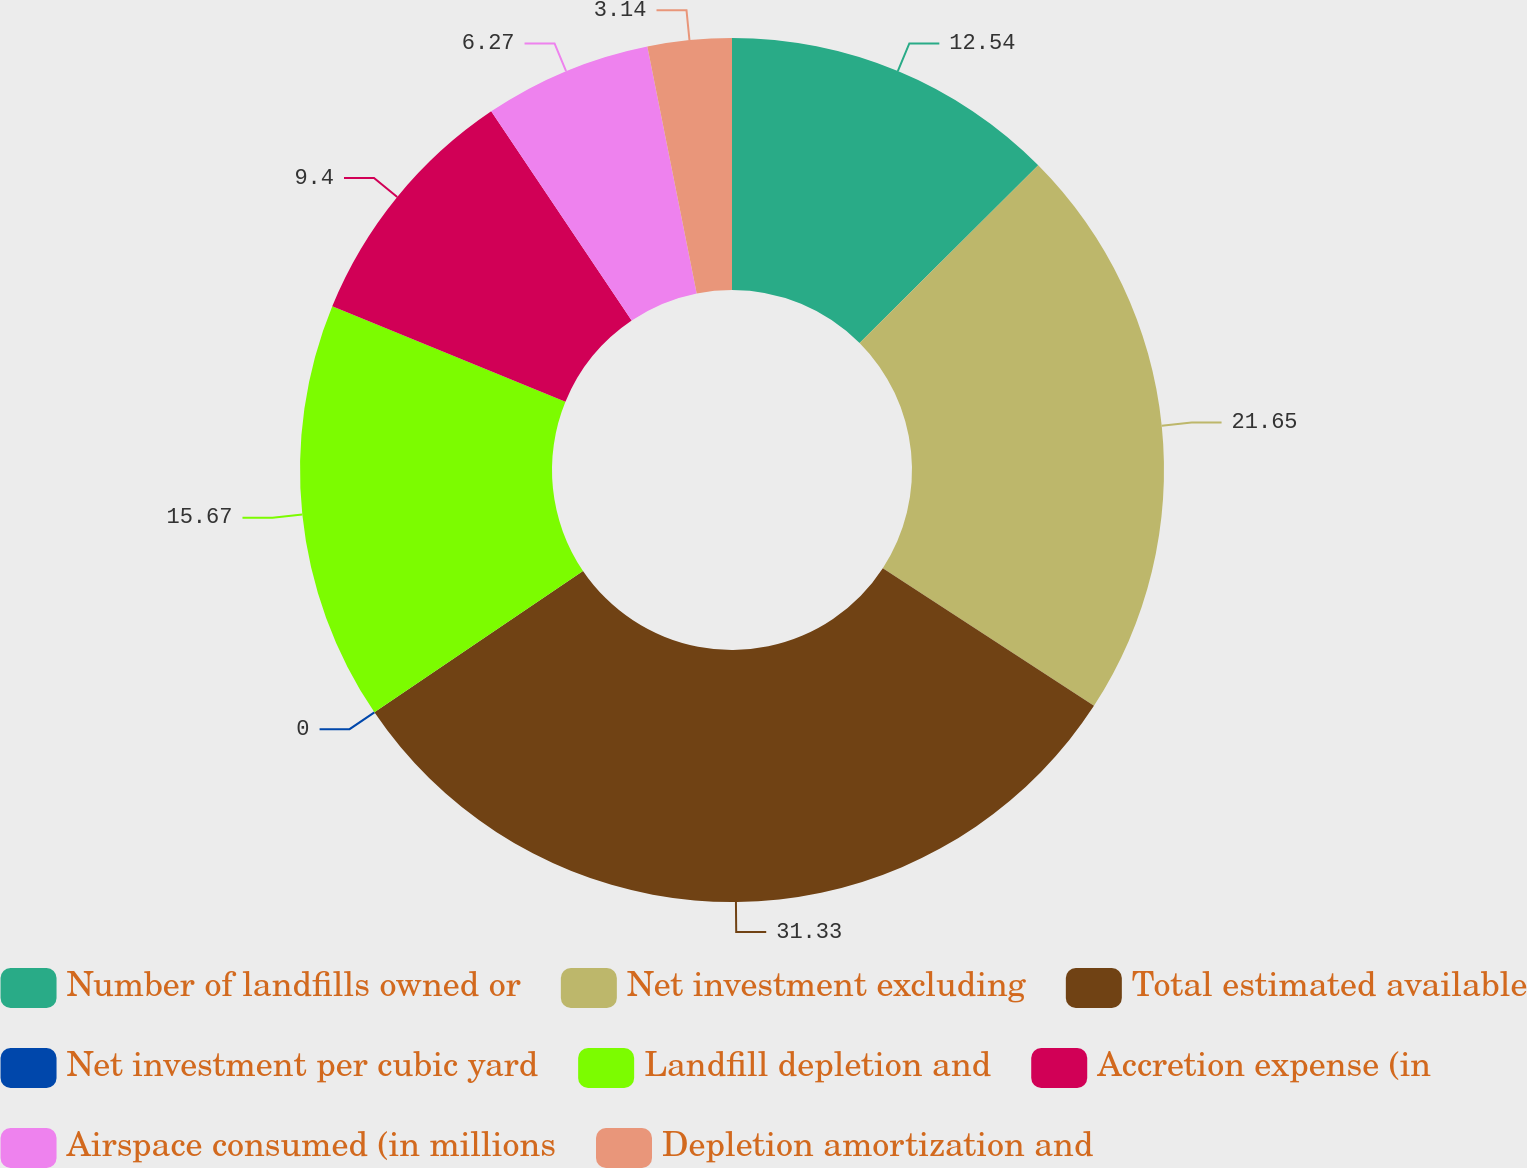Convert chart. <chart><loc_0><loc_0><loc_500><loc_500><pie_chart><fcel>Number of landfills owned or<fcel>Net investment excluding<fcel>Total estimated available<fcel>Net investment per cubic yard<fcel>Landfill depletion and<fcel>Accretion expense (in<fcel>Airspace consumed (in millions<fcel>Depletion amortization and<nl><fcel>12.54%<fcel>21.65%<fcel>31.33%<fcel>0.0%<fcel>15.67%<fcel>9.4%<fcel>6.27%<fcel>3.14%<nl></chart> 